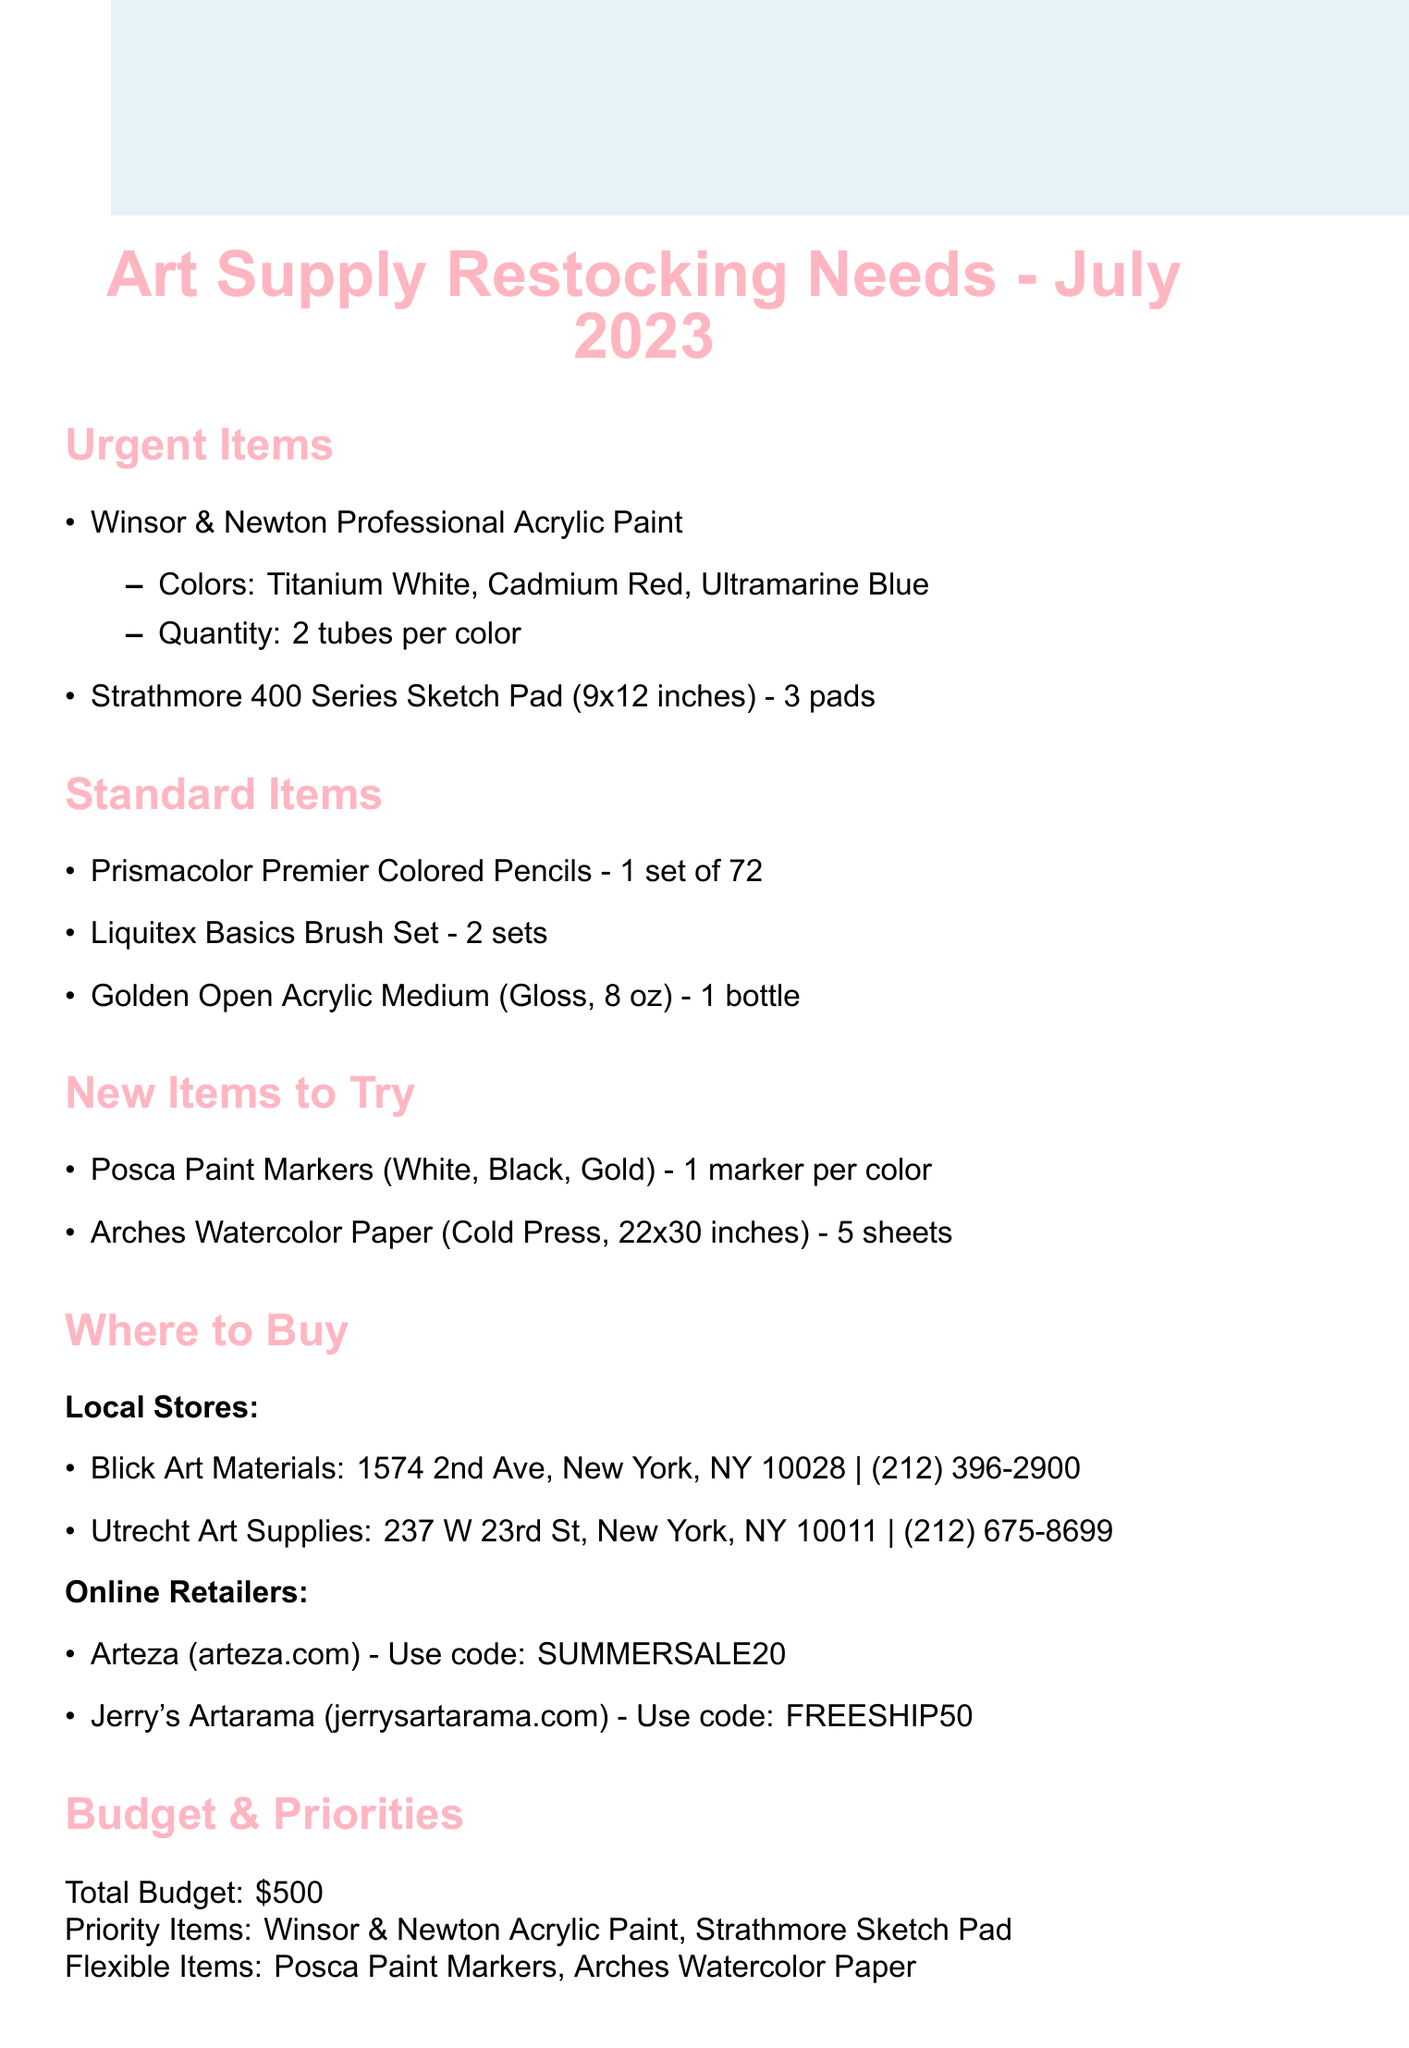what are the urgent items listed? The urgent items are the key supplies that need to be restocked urgently, which include the Winsor & Newton Professional Acrylic Paint and the Strathmore 400 Series Sketch Pad.
Answer: Winsor & Newton Professional Acrylic Paint, Strathmore 400 Series Sketch Pad how many tubes of Winsor & Newton Professional Acrylic Paint are needed? The document specifies the quantity of tubes needed for the Winsor & Newton Professional Acrylic Paint, which is indicated for each color.
Answer: 2 tubes per color what is the total budget for restocking supplies? The total budget is clearly stated at the beginning of the budget considerations section.
Answer: 500 what online retailer offers a promo code? The document lists online retailers along with their respective promo codes for discounts.
Answer: Arteza, Jerry's Artarama which item is listed under new items to try? New items to try section contains new art supplies that the artist is considering for future use, one of which is highlighted.
Answer: Posca Paint Markers how many sheets of Arches Watercolor Paper are needed? The quantity of Arches Watercolor Paper required is provided in the new items to try section of the document.
Answer: 5 sheets when does the Summer Cityscape Series project start? The start date for the Summer Cityscape Series project is mentioned in the upcoming projects section of the document.
Answer: July 15, 2023 what is the priority item listed? The priority items are specified to help guide purchasing and restocking decisions based on importance.
Answer: Winsor & Newton Acrylic Paint, Strathmore Sketch Pad 